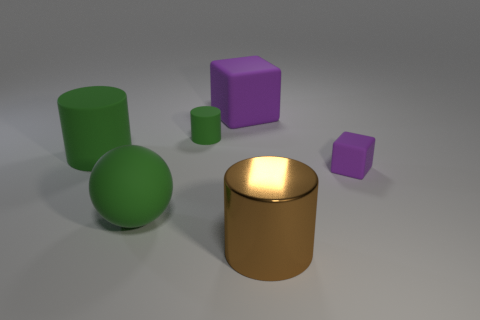How many objects are either purple rubber objects left of the brown metallic cylinder or tiny green matte cylinders?
Your answer should be compact. 2. Is the color of the big ball the same as the tiny matte cube?
Offer a very short reply. No. What size is the thing in front of the big ball?
Give a very brief answer. Large. Is there another object of the same size as the brown shiny thing?
Give a very brief answer. Yes. Is the size of the purple block right of the metallic cylinder the same as the big green cylinder?
Keep it short and to the point. No. What is the size of the metallic cylinder?
Your answer should be very brief. Large. There is a cylinder that is in front of the green matte cylinder that is in front of the small green cylinder that is behind the big green rubber cylinder; what color is it?
Give a very brief answer. Brown. Is the color of the cube that is behind the tiny purple matte object the same as the big ball?
Make the answer very short. No. How many cylinders are on the right side of the big cube and left of the green sphere?
Offer a very short reply. 0. What size is the other purple thing that is the same shape as the tiny purple thing?
Your response must be concise. Large. 